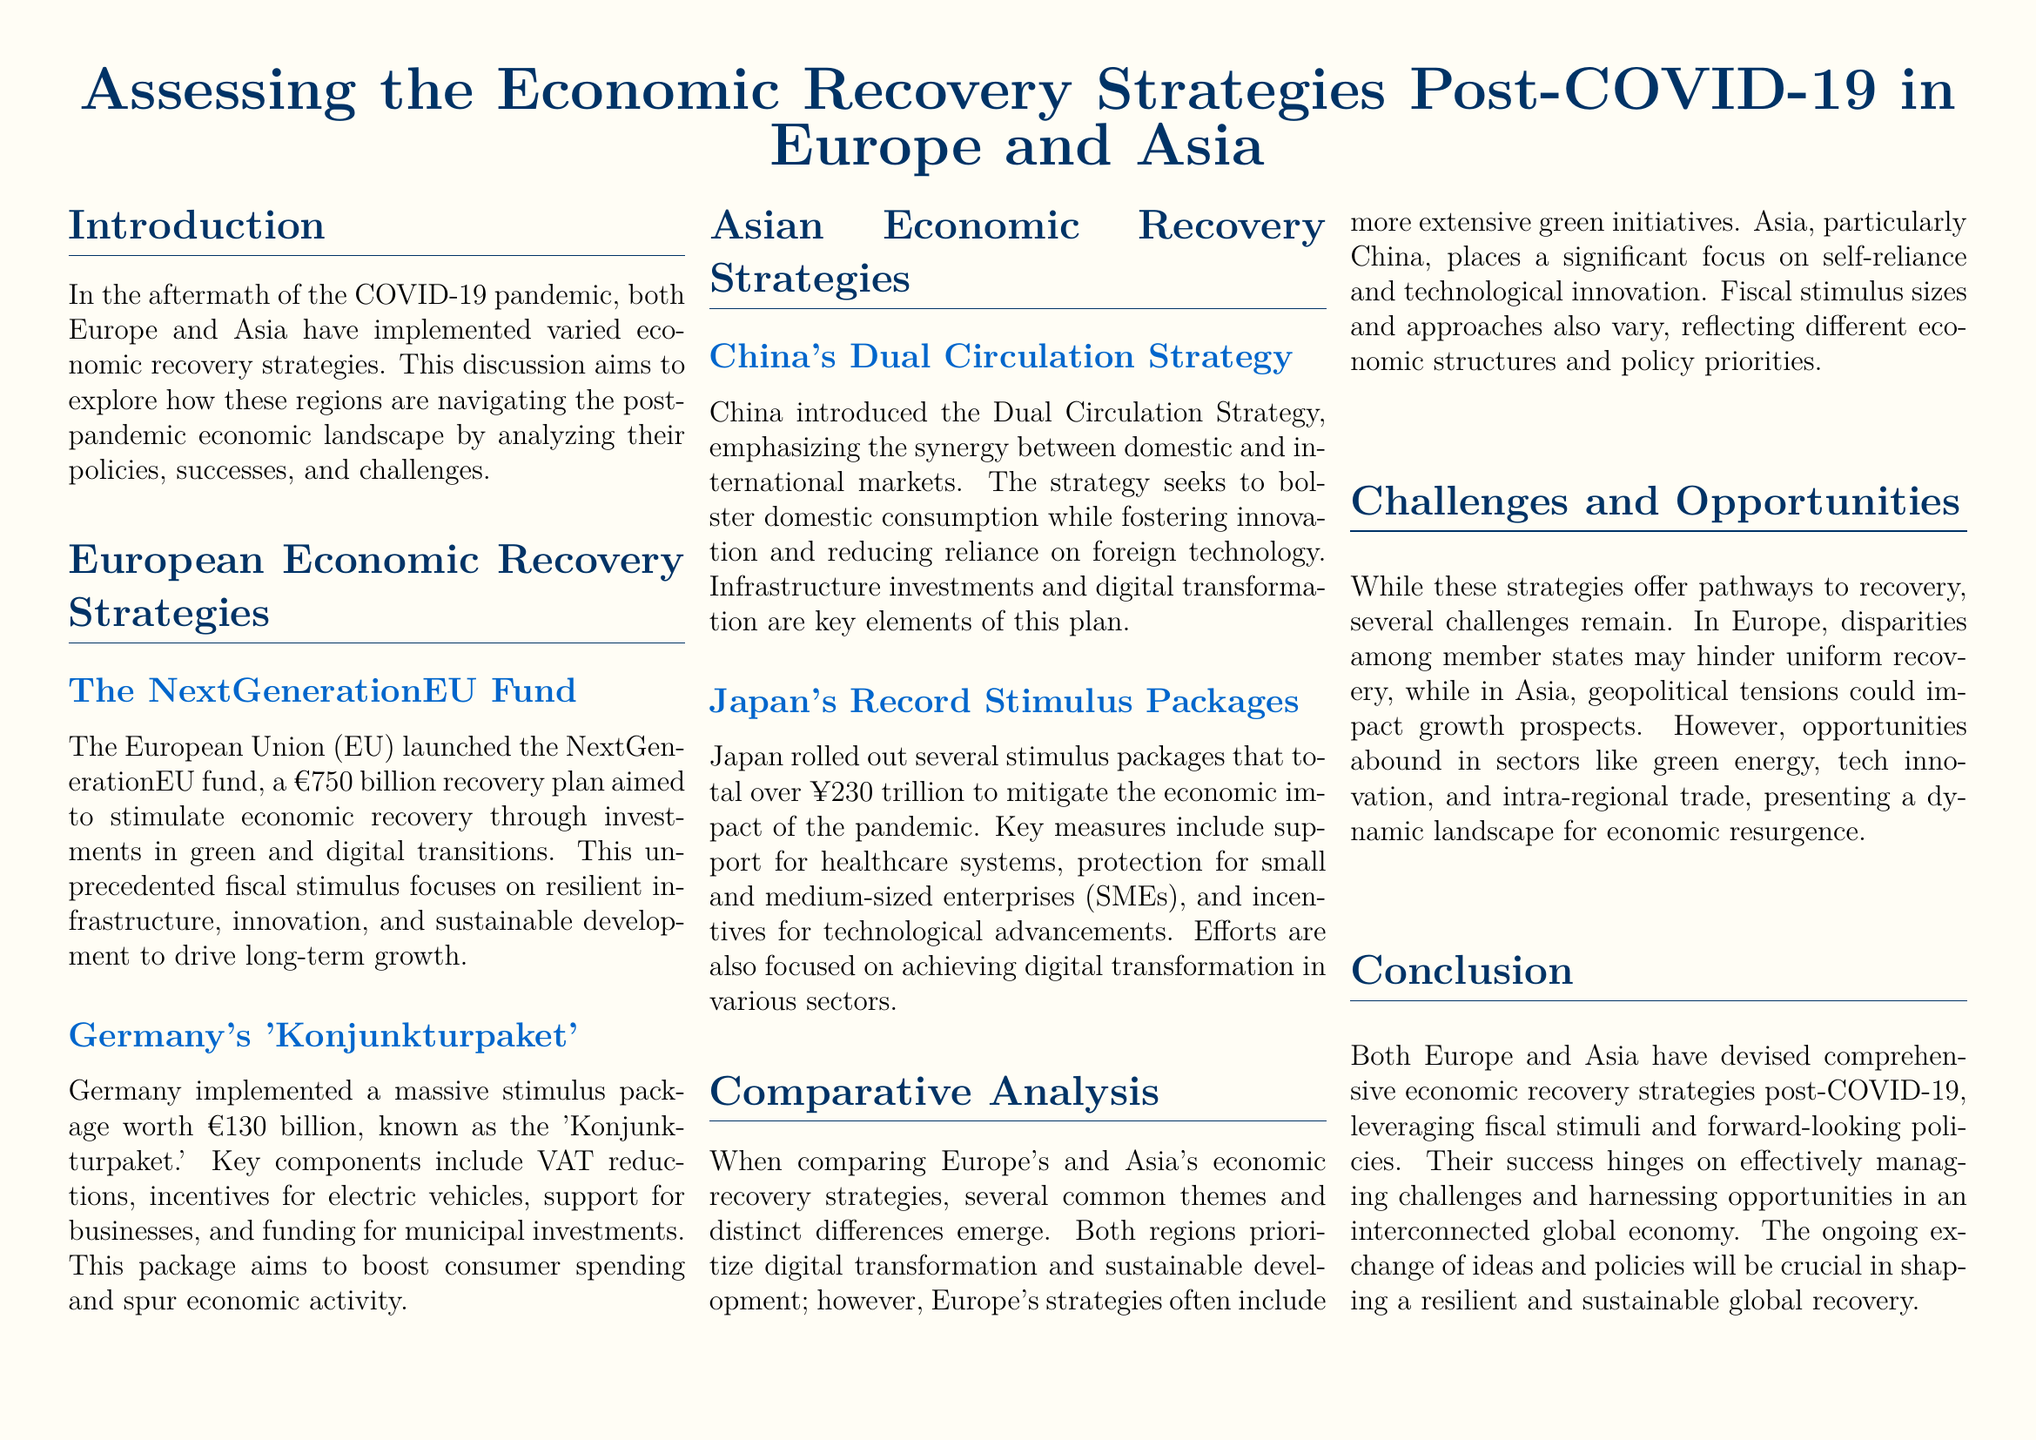What is the total amount of the NextGenerationEU fund? The document states that the NextGenerationEU fund is a €750 billion recovery plan.
Answer: €750 billion What is the name of Germany's economic recovery package? The document refers to Germany's recovery package as the 'Konjunkturpaket.'
Answer: 'Konjunkturpaket' How much has Japan allocated for its stimulus packages? The total amount for Japan's stimulus packages mentioned in the document is over ¥230 trillion.
Answer: over ¥230 trillion What is the main focus of China's Dual Circulation Strategy? The strategy emphasizes the synergy between domestic and international markets, as discussed in the document.
Answer: synergy between domestic and international markets What key theme is common in both Europe's and Asia's recovery strategies? The document highlights digital transformation as a common priority for both regions.
Answer: digital transformation What major challenge does Europe face in its recovery? According to the document, disparities among member states may hinder uniform recovery in Europe.
Answer: disparities among member states What does the document mention as a significant focus in China’s recovery strategy? The document indicates that China places a significant focus on self-reliance and technological innovation.
Answer: self-reliance and technological innovation In what sectors are opportunities for economic resurgence mentioned in the document? The document lists green energy, tech innovation, and intra-regional trade as sectors with opportunities.
Answer: green energy, tech innovation, intra-regional trade What is identified as a crucial factor for success in recovery strategies according to the conclusion? The conclusion emphasizes the ongoing exchange of ideas and policies as crucial for success.
Answer: ongoing exchange of ideas and policies 